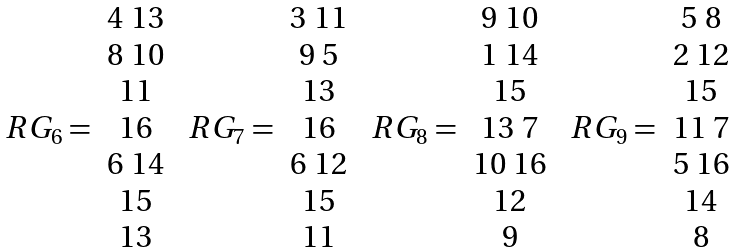Convert formula to latex. <formula><loc_0><loc_0><loc_500><loc_500>\begin{array} { c c } & 4 \ 1 3 \\ & 8 \ 1 0 \\ & 1 1 \\ R G _ { 6 } = & 1 6 \\ & 6 \ 1 4 \\ & 1 5 \\ & 1 3 \\ \end{array} \ \begin{array} { c c } & 3 \ 1 1 \\ & 9 \ 5 \\ & 1 3 \\ R G _ { 7 } = & 1 6 \\ & 6 \ 1 2 \\ & 1 5 \\ & 1 1 \\ \end{array} \ \begin{array} { c c } & 9 \ 1 0 \\ & 1 \ 1 4 \\ & 1 5 \\ R G _ { 8 } = & 1 3 \ 7 \\ & 1 0 \ 1 6 \\ & 1 2 \\ & 9 \\ \end{array} \ \begin{array} { c c } & 5 \ 8 \\ & 2 \ 1 2 \\ & 1 5 \\ R G _ { 9 } = & 1 1 \ 7 \\ & 5 \ 1 6 \\ & 1 4 \\ & 8 \\ \end{array}</formula> 